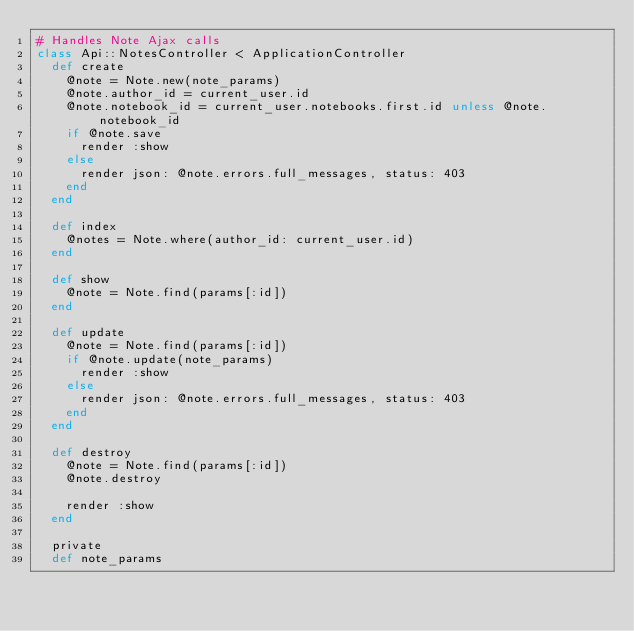Convert code to text. <code><loc_0><loc_0><loc_500><loc_500><_Ruby_># Handles Note Ajax calls
class Api::NotesController < ApplicationController
  def create
    @note = Note.new(note_params)
    @note.author_id = current_user.id
    @note.notebook_id = current_user.notebooks.first.id unless @note.notebook_id
    if @note.save
      render :show
    else
      render json: @note.errors.full_messages, status: 403
    end
  end

  def index
    @notes = Note.where(author_id: current_user.id)
  end

  def show
    @note = Note.find(params[:id])
  end

  def update
    @note = Note.find(params[:id])
    if @note.update(note_params)
      render :show
    else
      render json: @note.errors.full_messages, status: 403
    end
  end

  def destroy
    @note = Note.find(params[:id])
    @note.destroy

    render :show
  end

  private
  def note_params</code> 